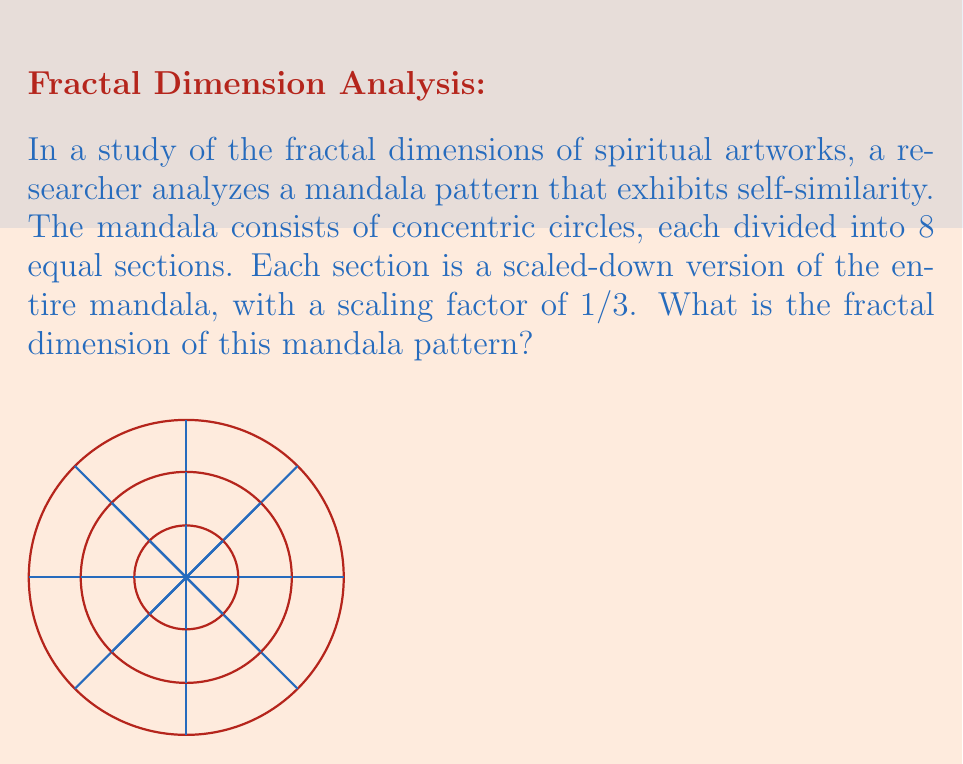Solve this math problem. To determine the fractal dimension of this mandala pattern, we'll use the box-counting dimension formula:

$$ D = \frac{\log N}{\log(1/r)} $$

Where:
- $D$ is the fractal dimension
- $N$ is the number of self-similar pieces
- $r$ is the scaling factor

For this mandala:
1. We have 8 self-similar sections in each iteration, so $N = 8$
2. The scaling factor is given as 1/3, so $r = 1/3$

Let's substitute these values into the formula:

$$ D = \frac{\log 8}{\log(1/(1/3))} = \frac{\log 8}{\log 3} $$

Using a calculator or computer, we can evaluate this:

$$ D \approx 1.8927 $$

This value is between 1 and 2, which is typical for fractal patterns in 2D space. It indicates that the mandala pattern has a complexity that's greater than a simple line (dimension 1) but less than a filled plane (dimension 2).
Answer: $\frac{\log 8}{\log 3} \approx 1.8927$ 